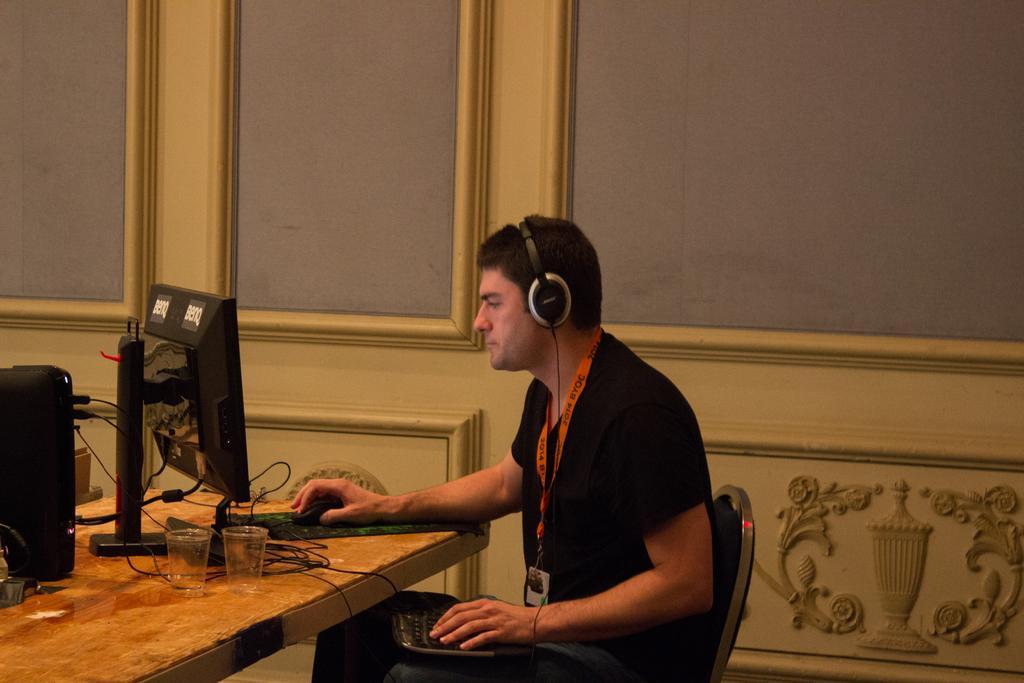Can you describe this image briefly? In this picture we can see man sitting on chair and typing on keyboard with one hand and other hand on mouse looking at monitor and here on table we can see glasses, CPU, wires and in background we can see wall. 